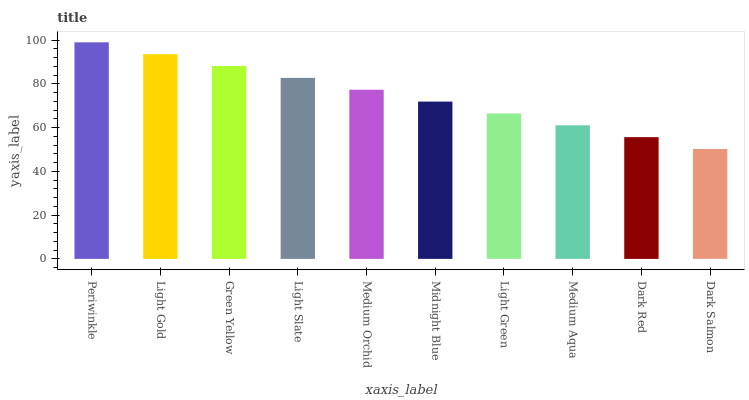Is Dark Salmon the minimum?
Answer yes or no. Yes. Is Periwinkle the maximum?
Answer yes or no. Yes. Is Light Gold the minimum?
Answer yes or no. No. Is Light Gold the maximum?
Answer yes or no. No. Is Periwinkle greater than Light Gold?
Answer yes or no. Yes. Is Light Gold less than Periwinkle?
Answer yes or no. Yes. Is Light Gold greater than Periwinkle?
Answer yes or no. No. Is Periwinkle less than Light Gold?
Answer yes or no. No. Is Medium Orchid the high median?
Answer yes or no. Yes. Is Midnight Blue the low median?
Answer yes or no. Yes. Is Medium Aqua the high median?
Answer yes or no. No. Is Dark Red the low median?
Answer yes or no. No. 